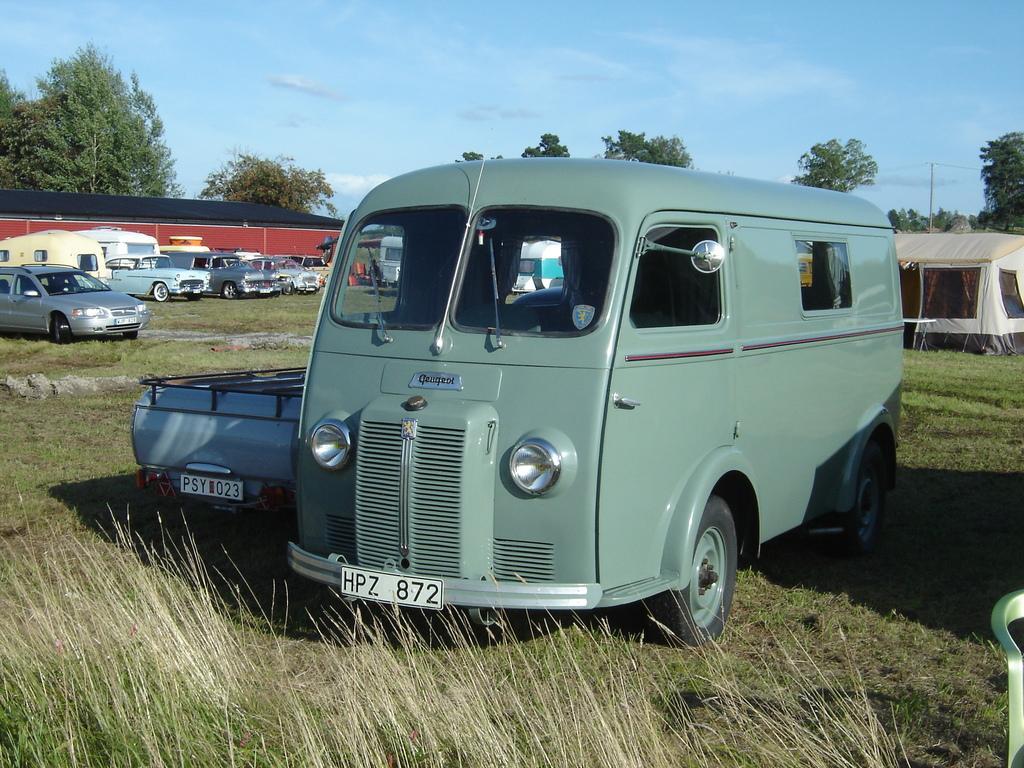Describe this image in one or two sentences. In the picture there are some vehicles parked on the grass and behind the vehicles there is a tent in between the grass and on the left side there is a compartment behind the vehicles and around the land there are many trees. 